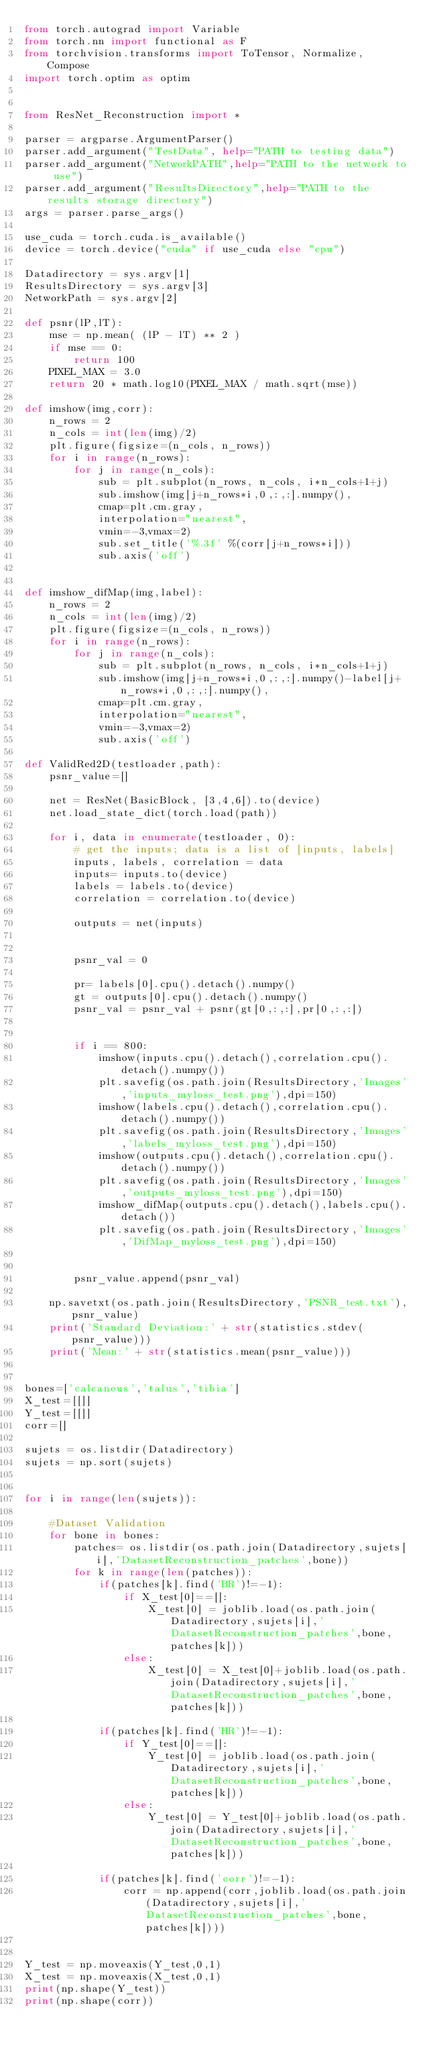Convert code to text. <code><loc_0><loc_0><loc_500><loc_500><_Python_>from torch.autograd import Variable
from torch.nn import functional as F
from torchvision.transforms import ToTensor, Normalize, Compose
import torch.optim as optim


from ResNet_Reconstruction import *

parser = argparse.ArgumentParser()
parser.add_argument("TestData", help="PATH to testing data")
parser.add_argument("NetworkPATH",help="PATH to the network to use")
parser.add_argument("ResultsDirectory",help="PATH to the results storage directory")
args = parser.parse_args()

use_cuda = torch.cuda.is_available()
device = torch.device("cuda" if use_cuda else "cpu")

Datadirectory = sys.argv[1]
ResultsDirectory = sys.argv[3]
NetworkPath = sys.argv[2]

def psnr(lP,lT):
    mse = np.mean( (lP - lT) ** 2 )
    if mse == 0:
        return 100
    PIXEL_MAX = 3.0
    return 20 * math.log10(PIXEL_MAX / math.sqrt(mse))

def imshow(img,corr):
	n_rows = 2
	n_cols = int(len(img)/2)
	plt.figure(figsize=(n_cols, n_rows))
	for i in range(n_rows):
		for j in range(n_cols):
			sub = plt.subplot(n_rows, n_cols, i*n_cols+1+j)
			sub.imshow(img[j+n_rows*i,0,:,:].numpy(),
		 	cmap=plt.cm.gray,
		 	interpolation="nearest",
		 	vmin=-3,vmax=2)
			sub.set_title('%.3f' %(corr[j+n_rows*i]))
			sub.axis('off')
	

def imshow_difMap(img,label):
	n_rows = 2
	n_cols = int(len(img)/2)
	plt.figure(figsize=(n_cols, n_rows))
	for i in range(n_rows):
		for j in range(n_cols):
			sub = plt.subplot(n_rows, n_cols, i*n_cols+1+j)
			sub.imshow(img[j+n_rows*i,0,:,:].numpy()-label[j+n_rows*i,0,:,:].numpy(),
		 	cmap=plt.cm.gray,
		 	interpolation="nearest",
		 	vmin=-3,vmax=2)
			sub.axis('off')
            
def ValidRed2D(testloader,path):
    psnr_value=[]
    
    net = ResNet(BasicBlock, [3,4,6]).to(device)
    net.load_state_dict(torch.load(path))
    
    for i, data in enumerate(testloader, 0):
        # get the inputs; data is a list of [inputs, labels]
        inputs, labels, correlation = data
        inputs= inputs.to(device)
        labels = labels.to(device)
        correlation = correlation.to(device)
	
        outputs = net(inputs)

	
        psnr_val = 0
	
        pr= labels[0].cpu().detach().numpy()
        gt = outputs[0].cpu().detach().numpy()
        psnr_val = psnr_val + psnr(gt[0,:,:],pr[0,:,:])
	
	
        if i == 800:
            imshow(inputs.cpu().detach(),correlation.cpu().detach().numpy())
            plt.savefig(os.path.join(ResultsDirectory,'Images','inputs_myloss_test.png'),dpi=150)
            imshow(labels.cpu().detach(),correlation.cpu().detach().numpy())
            plt.savefig(os.path.join(ResultsDirectory,'Images','labels_myloss_test.png'),dpi=150)
            imshow(outputs.cpu().detach(),correlation.cpu().detach().numpy())
            plt.savefig(os.path.join(ResultsDirectory,'Images','outputs_myloss_test.png'),dpi=150)
            imshow_difMap(outputs.cpu().detach(),labels.cpu().detach())
            plt.savefig(os.path.join(ResultsDirectory,'Images','DifMap_myloss_test.png'),dpi=150)
	
            
        psnr_value.append(psnr_val)
            
    np.savetxt(os.path.join(ResultsDirectory,'PSNR_test.txt'),psnr_value)
    print('Standard Deviation:' + str(statistics.stdev(psnr_value)))
    print('Mean:' + str(statistics.mean(psnr_value)))
    

bones=['calcaneus','talus','tibia'] 
X_test=[[]]
Y_test=[[]]  
corr=[]
 
sujets = os.listdir(Datadirectory)
sujets = np.sort(sujets)


for i in range(len(sujets)):
	
    #Dataset Validation
    for bone in bones:
        patches= os.listdir(os.path.join(Datadirectory,sujets[i],'DatasetReconstruction_patches',bone))
        for k in range(len(patches)):
            if(patches[k].find('BR')!=-1):
                if X_test[0]==[]:
                    X_test[0] = joblib.load(os.path.join(Datadirectory,sujets[i],'DatasetReconstruction_patches',bone,patches[k]))
                else:
                    X_test[0] = X_test[0]+joblib.load(os.path.join(Datadirectory,sujets[i],'DatasetReconstruction_patches',bone,patches[k]))
    	   
            if(patches[k].find('HR')!=-1):
                if Y_test[0]==[]:
                    Y_test[0] = joblib.load(os.path.join(Datadirectory,sujets[i],'DatasetReconstruction_patches',bone,patches[k]))
                else:
                    Y_test[0] = Y_test[0]+joblib.load(os.path.join(Datadirectory,sujets[i],'DatasetReconstruction_patches',bone,patches[k]))
            
            if(patches[k].find('corr')!=-1):
                corr = np.append(corr,joblib.load(os.path.join(Datadirectory,sujets[i],'DatasetReconstruction_patches',bone,patches[k])))		
	

Y_test = np.moveaxis(Y_test,0,1)
X_test = np.moveaxis(X_test,0,1)
print(np.shape(Y_test))
print(np.shape(corr))

</code> 